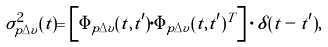Convert formula to latex. <formula><loc_0><loc_0><loc_500><loc_500>\sigma _ { p \Delta v } ^ { 2 } ( t ) = \left [ \Phi _ { p \Delta v } ( t , t ^ { \prime } ) \cdot \Phi _ { p \Delta v } ( t , t ^ { \prime } ) ^ { T } \right ] \cdot \delta ( t - t ^ { \prime } ) ,</formula> 